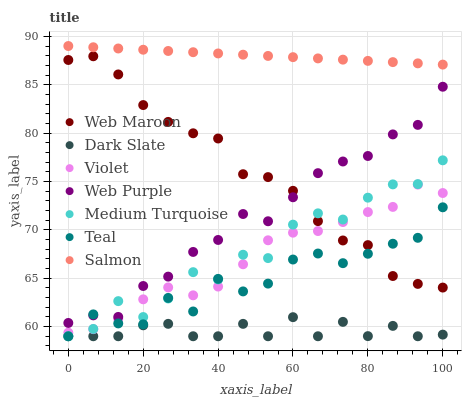Does Dark Slate have the minimum area under the curve?
Answer yes or no. Yes. Does Salmon have the maximum area under the curve?
Answer yes or no. Yes. Does Web Maroon have the minimum area under the curve?
Answer yes or no. No. Does Web Maroon have the maximum area under the curve?
Answer yes or no. No. Is Salmon the smoothest?
Answer yes or no. Yes. Is Medium Turquoise the roughest?
Answer yes or no. Yes. Is Web Maroon the smoothest?
Answer yes or no. No. Is Web Maroon the roughest?
Answer yes or no. No. Does Medium Turquoise have the lowest value?
Answer yes or no. Yes. Does Web Maroon have the lowest value?
Answer yes or no. No. Does Salmon have the highest value?
Answer yes or no. Yes. Does Web Maroon have the highest value?
Answer yes or no. No. Is Medium Turquoise less than Salmon?
Answer yes or no. Yes. Is Salmon greater than Medium Turquoise?
Answer yes or no. Yes. Does Web Purple intersect Teal?
Answer yes or no. Yes. Is Web Purple less than Teal?
Answer yes or no. No. Is Web Purple greater than Teal?
Answer yes or no. No. Does Medium Turquoise intersect Salmon?
Answer yes or no. No. 